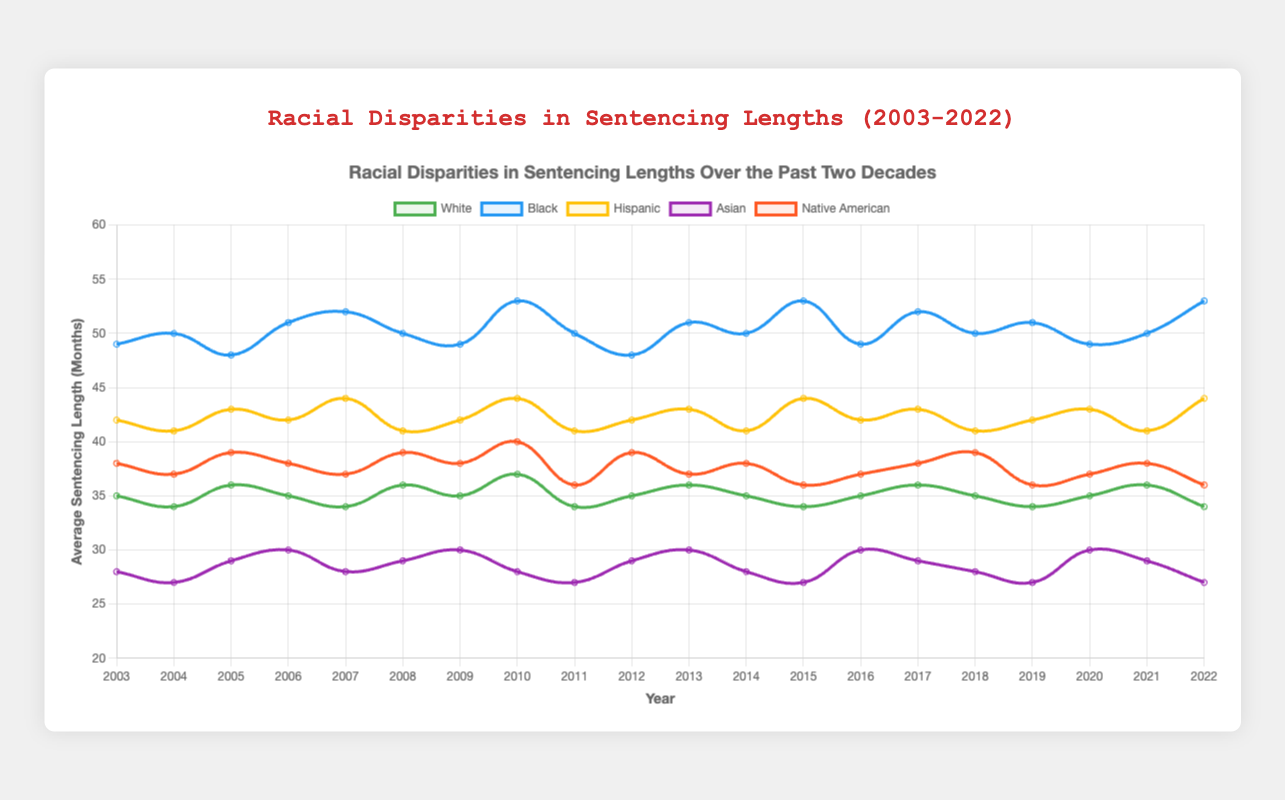What's the trend in the average sentencing length for Black individuals from 2003 to 2022? The figure shows a line chart for each racial group. For Black individuals, observe the blue line. It starts at 49 months in 2003, fluctuates around 50-53 months, and reaches 53 months in 2022.
Answer: Increasing trend with some fluctuations Which racial group consistently has the shortest average sentencing lengths over the years? The figure shows various colored lines for different racial groups. The purple line representing Asian individuals consistently has the shortest average sentencing lengths, ranging mostly from 27 to 30 months.
Answer: Asian In 2022, which racial group experienced the highest average sentencing length? The figure has different lines for each group. In 2022, the highest point belongs to the blue line representing Black individuals, with an average sentencing length of 53 months.
Answer: Black By how many months did the average sentencing length for Hispanic individuals change from 2003 to 2010? First, locate the yellow line representing Hispanic individuals. It starts at 42 months in 2003 and increases to 44 months in 2010. The change is 44 - 42 = 2 months.
Answer: 2 months Which racial group has the highest variability in average sentencing length over the years? Observe the fluctuation in the lines for each racial group. The Black line (blue) shows significant fluctuations ranging from 48 to 53 months, indicating the highest variability.
Answer: Black What is the combined average sentencing length for White and Native American individuals in 2005? Find the green and orange lines for the respective groups in 2005. White: 36 months, Native American: 39 months. Combined average=(36+39)/2=37.5 months.
Answer: 37.5 months Compare the average sentencing lengths for Asian and Hispanic individuals in 2015. Which group had shorter sentences? Locate 2015 on the x-axis and compare the respective lines. Asian: 27 months, Hispanic: 44 months. Asian individuals had shorter sentences.
Answer: Asian What year had the maximum difference in average sentencing length between White and Black individuals? Calculate the difference between green (White) and blue (Black) lines for every year. In 2010, the difference is the maximum (53 - 37 = 16 months).
Answer: 2010 How many years did White individuals have an average sentencing length of 34 months? Count the points where the green line hits 34 months. It occurs in 2004, 2007, 2011, 2015, 2019, and 2022, totaling 6 years.
Answer: 6 years What's the average of the median sentencing lengths from 2003 to 2022 across all racial groups? Calculate the median for each year by arranging the values and finding the middle. Average these medians over 20 years. Example 2003: (28, 35, 38, 42, 49), median=38 months, continue this for all years and then compute the average of these 20 median values. [Note: Calculation is complex and contextual; this summary provides the approach.]
Answer: [Calculation] 